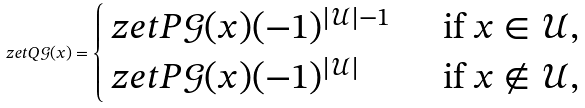<formula> <loc_0><loc_0><loc_500><loc_500>\ z e t { Q } { \mathcal { G } } ( x ) = \begin{cases} \ z e t { P } { \mathcal { G } } ( x ) ( - 1 ) ^ { | \mathcal { U } | - 1 } & \, \text { if } x \in \mathcal { U } , \\ \ z e t { P } { \mathcal { G } } ( x ) ( - 1 ) ^ { | \mathcal { U } | } & \, \text { if } x \notin \mathcal { U } , \end{cases}</formula> 